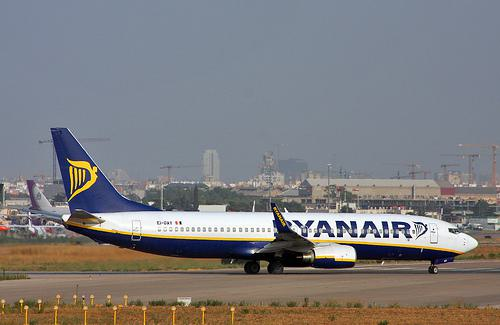Is this plane likely to be taking off or landing, and how can you tell? The airplane is likely taxiing or preparing for takeoff. This can be inferred from the position of the flaps, which do not appear to be fully extended as they would be for landing. Additionally, the lack of visible reverse thrust and the angle of the aircraft on the ground suggest it's not in the process of landing. 